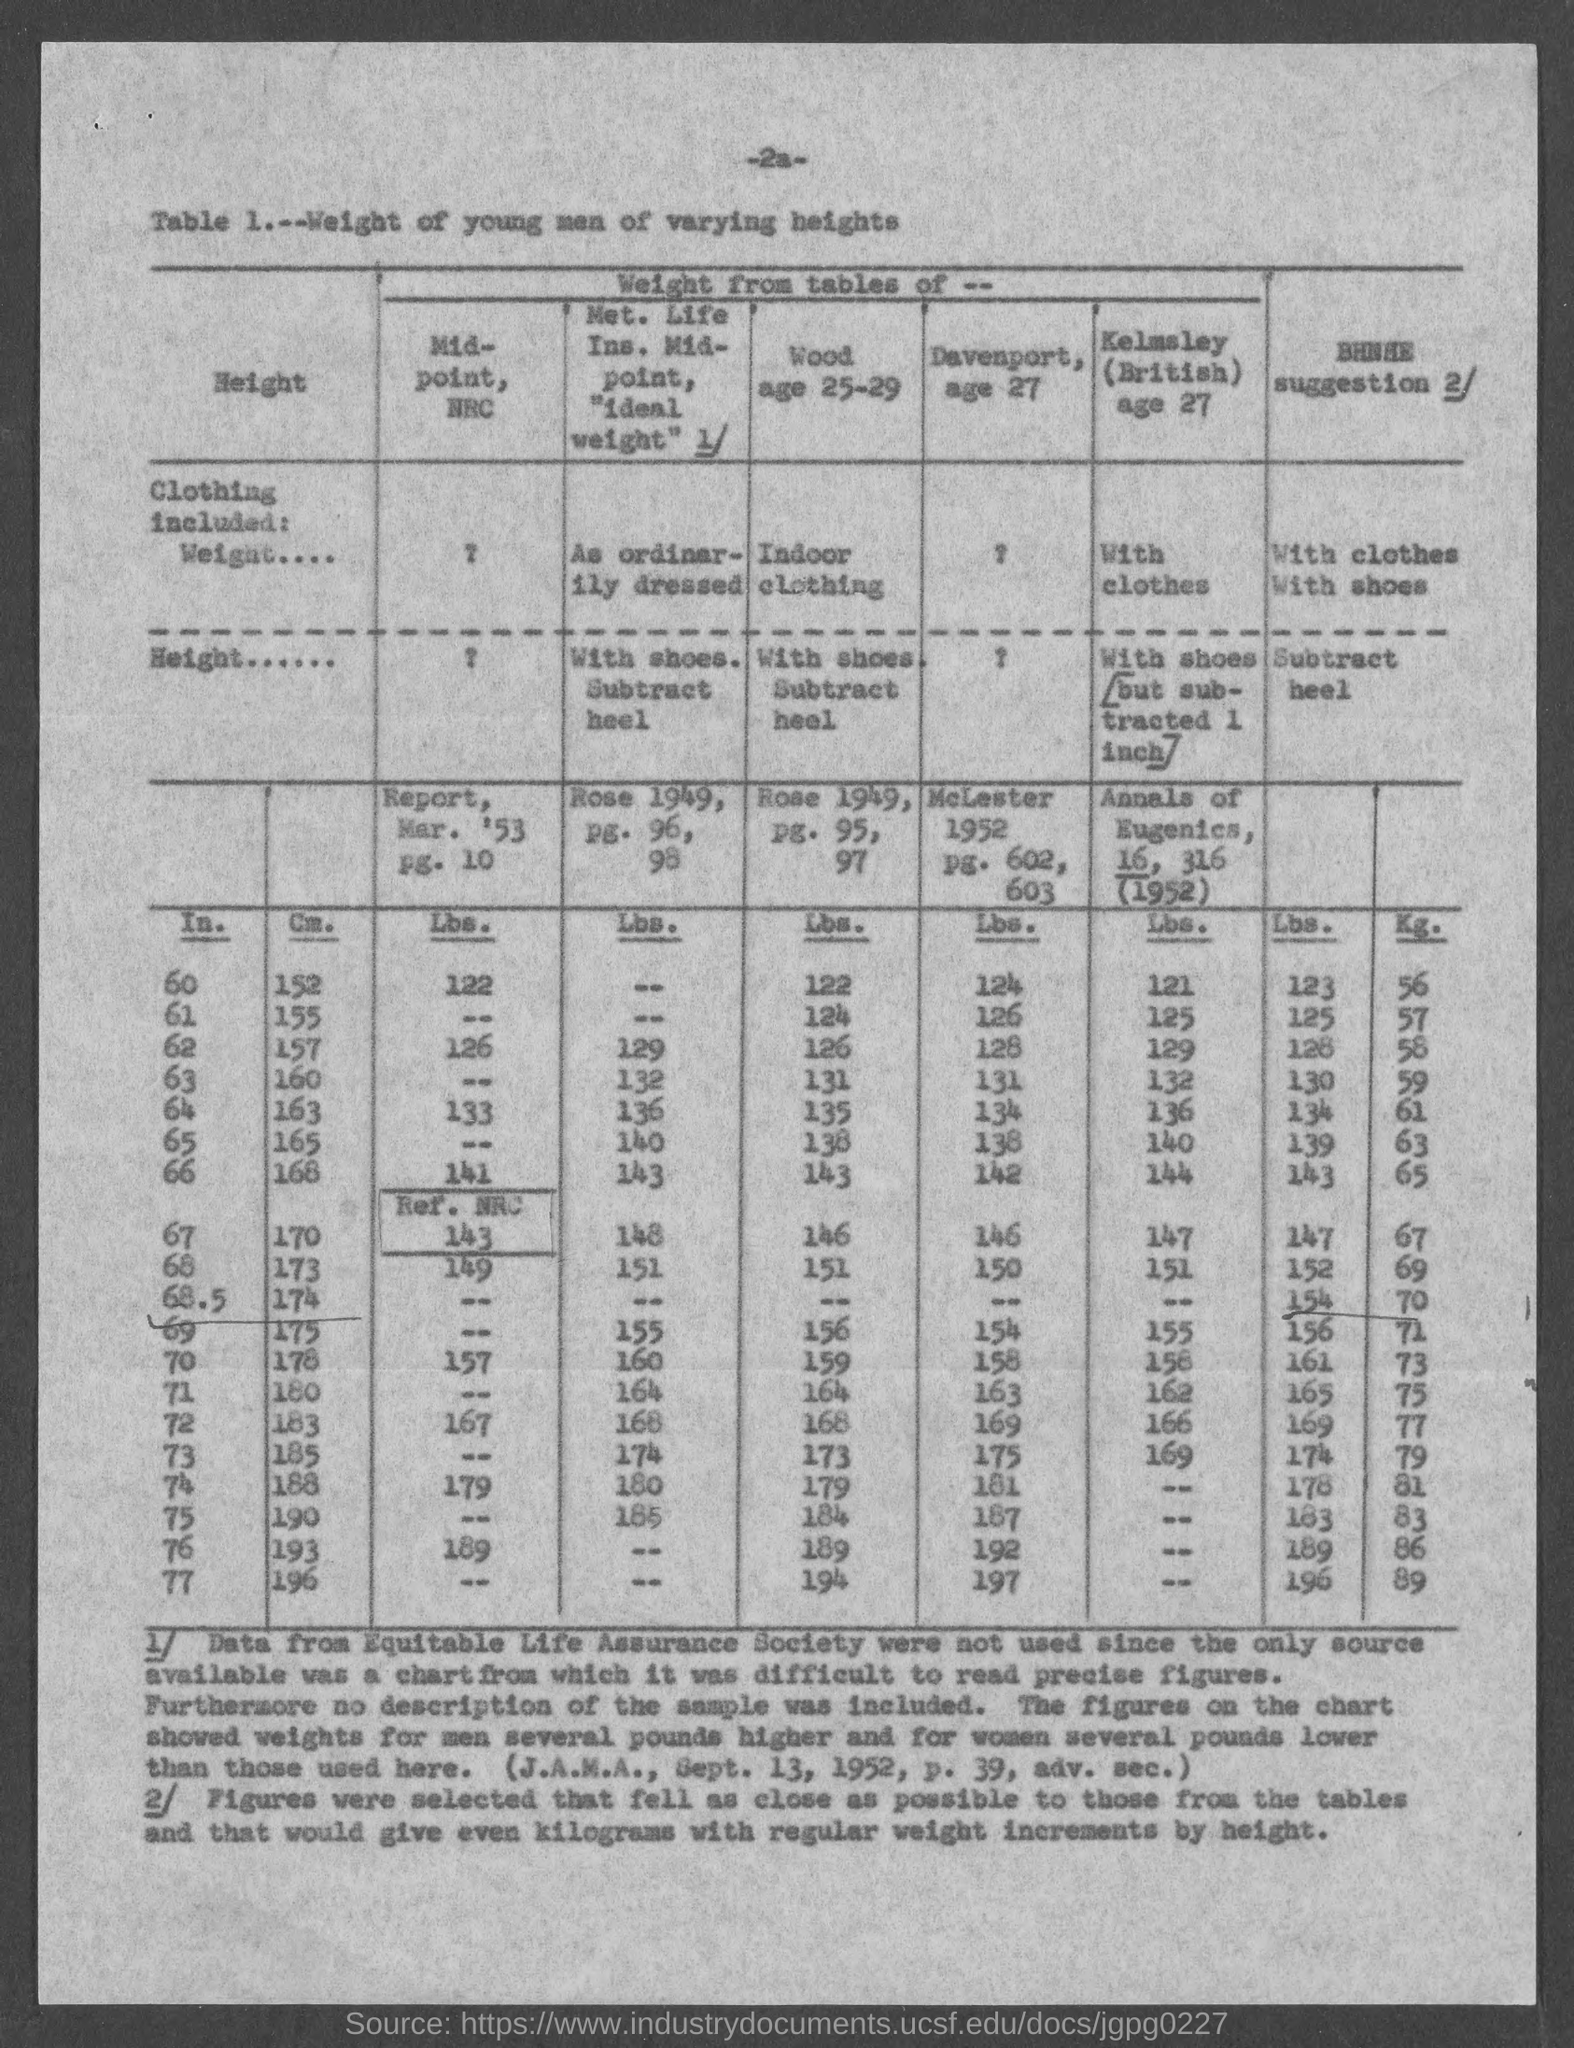Data from which Society were not used?
Offer a terse response. Equitable Life Assurance Society. 